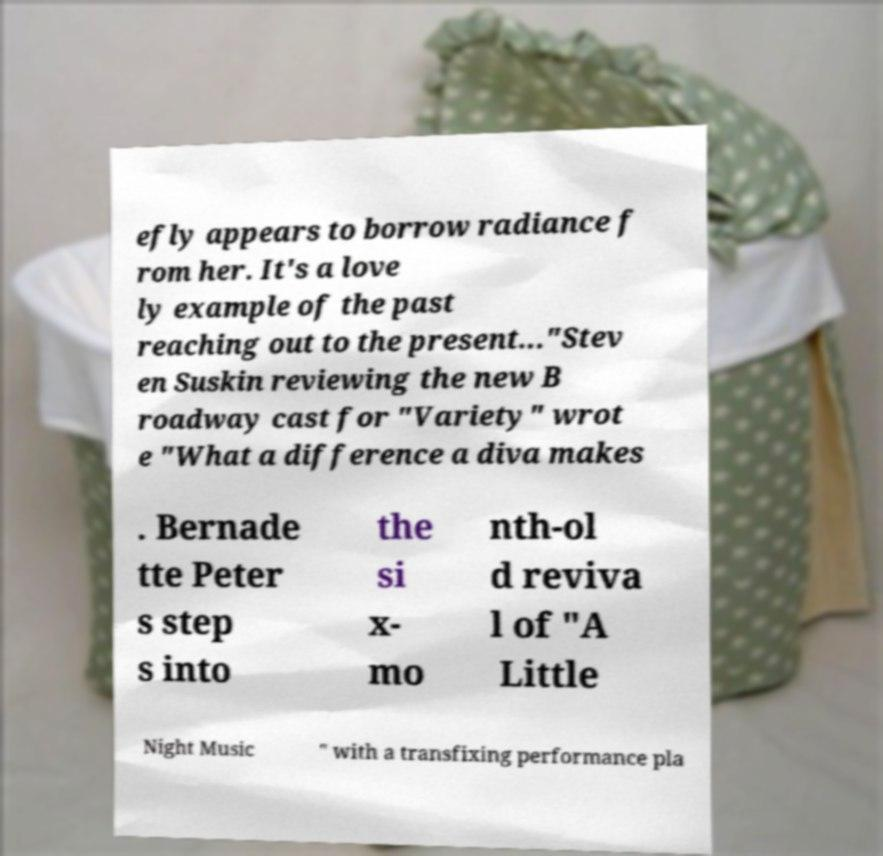Please read and relay the text visible in this image. What does it say? efly appears to borrow radiance f rom her. It's a love ly example of the past reaching out to the present..."Stev en Suskin reviewing the new B roadway cast for "Variety" wrot e "What a difference a diva makes . Bernade tte Peter s step s into the si x- mo nth-ol d reviva l of "A Little Night Music " with a transfixing performance pla 